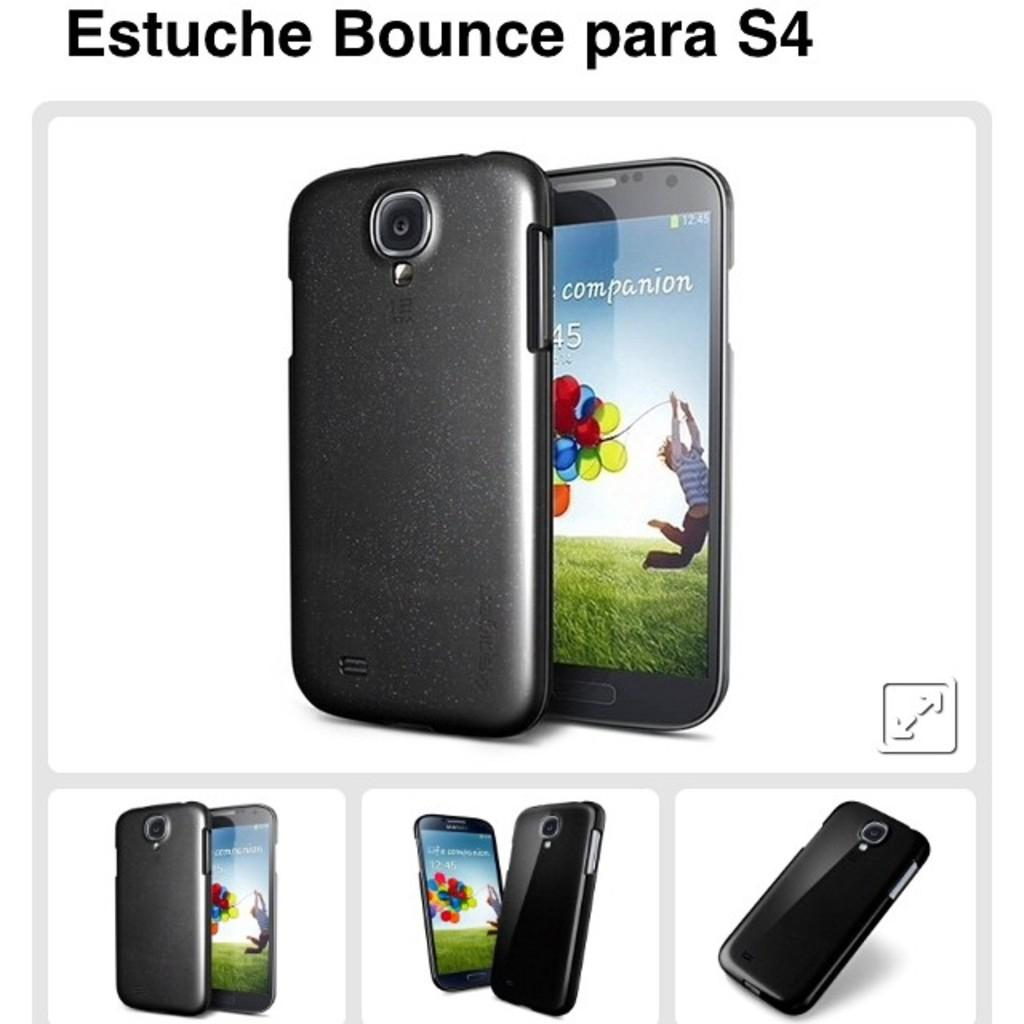<image>
Give a short and clear explanation of the subsequent image. An advertisement of a smart phone and it says on the top Estuche Bounce para S4. 